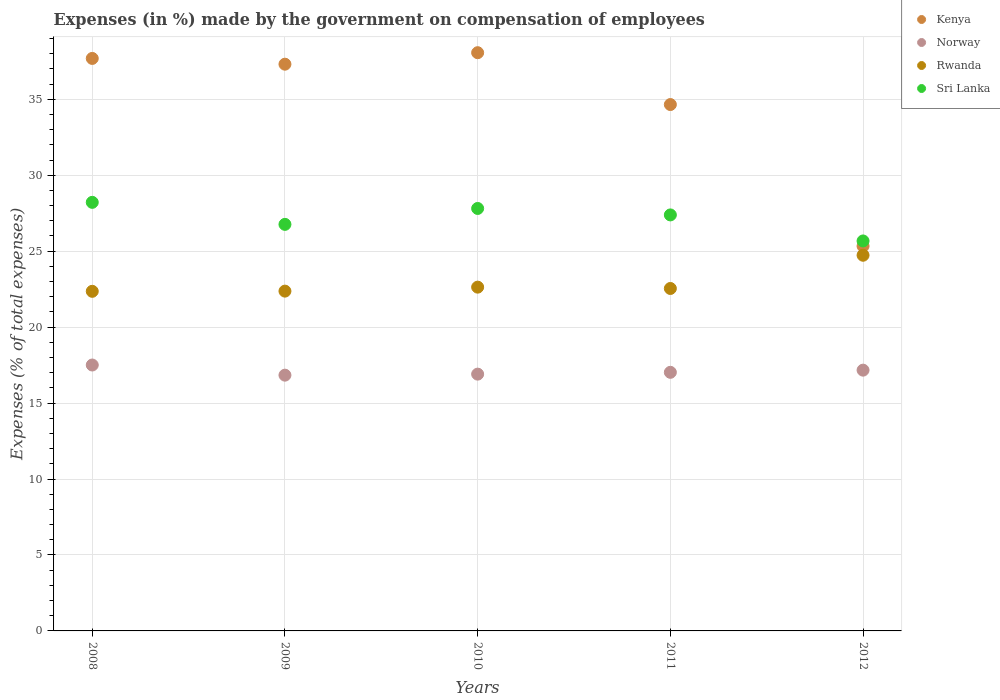Is the number of dotlines equal to the number of legend labels?
Keep it short and to the point. Yes. What is the percentage of expenses made by the government on compensation of employees in Rwanda in 2008?
Keep it short and to the point. 22.36. Across all years, what is the maximum percentage of expenses made by the government on compensation of employees in Norway?
Provide a short and direct response. 17.51. Across all years, what is the minimum percentage of expenses made by the government on compensation of employees in Rwanda?
Offer a terse response. 22.36. In which year was the percentage of expenses made by the government on compensation of employees in Norway maximum?
Offer a terse response. 2008. What is the total percentage of expenses made by the government on compensation of employees in Rwanda in the graph?
Provide a short and direct response. 114.63. What is the difference between the percentage of expenses made by the government on compensation of employees in Kenya in 2008 and that in 2012?
Your answer should be very brief. 12.36. What is the difference between the percentage of expenses made by the government on compensation of employees in Kenya in 2008 and the percentage of expenses made by the government on compensation of employees in Sri Lanka in 2010?
Give a very brief answer. 9.88. What is the average percentage of expenses made by the government on compensation of employees in Rwanda per year?
Your answer should be compact. 22.93. In the year 2008, what is the difference between the percentage of expenses made by the government on compensation of employees in Kenya and percentage of expenses made by the government on compensation of employees in Sri Lanka?
Make the answer very short. 9.47. What is the ratio of the percentage of expenses made by the government on compensation of employees in Sri Lanka in 2010 to that in 2012?
Give a very brief answer. 1.08. Is the percentage of expenses made by the government on compensation of employees in Rwanda in 2008 less than that in 2011?
Offer a very short reply. Yes. Is the difference between the percentage of expenses made by the government on compensation of employees in Kenya in 2010 and 2011 greater than the difference between the percentage of expenses made by the government on compensation of employees in Sri Lanka in 2010 and 2011?
Keep it short and to the point. Yes. What is the difference between the highest and the second highest percentage of expenses made by the government on compensation of employees in Rwanda?
Keep it short and to the point. 2.1. What is the difference between the highest and the lowest percentage of expenses made by the government on compensation of employees in Norway?
Your response must be concise. 0.67. In how many years, is the percentage of expenses made by the government on compensation of employees in Rwanda greater than the average percentage of expenses made by the government on compensation of employees in Rwanda taken over all years?
Make the answer very short. 1. Does the percentage of expenses made by the government on compensation of employees in Norway monotonically increase over the years?
Keep it short and to the point. No. How many years are there in the graph?
Your answer should be compact. 5. Does the graph contain any zero values?
Your answer should be compact. No. Does the graph contain grids?
Provide a short and direct response. Yes. How many legend labels are there?
Your answer should be compact. 4. How are the legend labels stacked?
Offer a terse response. Vertical. What is the title of the graph?
Make the answer very short. Expenses (in %) made by the government on compensation of employees. What is the label or title of the Y-axis?
Your answer should be compact. Expenses (% of total expenses). What is the Expenses (% of total expenses) of Kenya in 2008?
Provide a succinct answer. 37.69. What is the Expenses (% of total expenses) of Norway in 2008?
Ensure brevity in your answer.  17.51. What is the Expenses (% of total expenses) in Rwanda in 2008?
Your response must be concise. 22.36. What is the Expenses (% of total expenses) of Sri Lanka in 2008?
Offer a terse response. 28.21. What is the Expenses (% of total expenses) in Kenya in 2009?
Give a very brief answer. 37.31. What is the Expenses (% of total expenses) of Norway in 2009?
Make the answer very short. 16.84. What is the Expenses (% of total expenses) in Rwanda in 2009?
Offer a very short reply. 22.37. What is the Expenses (% of total expenses) in Sri Lanka in 2009?
Your answer should be compact. 26.76. What is the Expenses (% of total expenses) in Kenya in 2010?
Make the answer very short. 38.07. What is the Expenses (% of total expenses) of Norway in 2010?
Offer a terse response. 16.91. What is the Expenses (% of total expenses) in Rwanda in 2010?
Give a very brief answer. 22.63. What is the Expenses (% of total expenses) in Sri Lanka in 2010?
Give a very brief answer. 27.81. What is the Expenses (% of total expenses) of Kenya in 2011?
Offer a very short reply. 34.65. What is the Expenses (% of total expenses) in Norway in 2011?
Ensure brevity in your answer.  17.02. What is the Expenses (% of total expenses) in Rwanda in 2011?
Make the answer very short. 22.54. What is the Expenses (% of total expenses) in Sri Lanka in 2011?
Offer a terse response. 27.39. What is the Expenses (% of total expenses) in Kenya in 2012?
Keep it short and to the point. 25.33. What is the Expenses (% of total expenses) of Norway in 2012?
Your answer should be very brief. 17.17. What is the Expenses (% of total expenses) of Rwanda in 2012?
Provide a short and direct response. 24.73. What is the Expenses (% of total expenses) of Sri Lanka in 2012?
Make the answer very short. 25.67. Across all years, what is the maximum Expenses (% of total expenses) in Kenya?
Ensure brevity in your answer.  38.07. Across all years, what is the maximum Expenses (% of total expenses) of Norway?
Make the answer very short. 17.51. Across all years, what is the maximum Expenses (% of total expenses) of Rwanda?
Your response must be concise. 24.73. Across all years, what is the maximum Expenses (% of total expenses) in Sri Lanka?
Make the answer very short. 28.21. Across all years, what is the minimum Expenses (% of total expenses) in Kenya?
Your answer should be compact. 25.33. Across all years, what is the minimum Expenses (% of total expenses) of Norway?
Your answer should be very brief. 16.84. Across all years, what is the minimum Expenses (% of total expenses) of Rwanda?
Offer a very short reply. 22.36. Across all years, what is the minimum Expenses (% of total expenses) of Sri Lanka?
Provide a short and direct response. 25.67. What is the total Expenses (% of total expenses) in Kenya in the graph?
Your answer should be compact. 173.05. What is the total Expenses (% of total expenses) in Norway in the graph?
Keep it short and to the point. 85.44. What is the total Expenses (% of total expenses) in Rwanda in the graph?
Your answer should be compact. 114.63. What is the total Expenses (% of total expenses) in Sri Lanka in the graph?
Keep it short and to the point. 135.85. What is the difference between the Expenses (% of total expenses) in Kenya in 2008 and that in 2009?
Ensure brevity in your answer.  0.38. What is the difference between the Expenses (% of total expenses) of Norway in 2008 and that in 2009?
Provide a succinct answer. 0.67. What is the difference between the Expenses (% of total expenses) of Rwanda in 2008 and that in 2009?
Make the answer very short. -0.01. What is the difference between the Expenses (% of total expenses) of Sri Lanka in 2008 and that in 2009?
Your answer should be compact. 1.45. What is the difference between the Expenses (% of total expenses) of Kenya in 2008 and that in 2010?
Keep it short and to the point. -0.38. What is the difference between the Expenses (% of total expenses) of Norway in 2008 and that in 2010?
Ensure brevity in your answer.  0.6. What is the difference between the Expenses (% of total expenses) of Rwanda in 2008 and that in 2010?
Your answer should be compact. -0.27. What is the difference between the Expenses (% of total expenses) of Sri Lanka in 2008 and that in 2010?
Provide a short and direct response. 0.4. What is the difference between the Expenses (% of total expenses) in Kenya in 2008 and that in 2011?
Your answer should be compact. 3.04. What is the difference between the Expenses (% of total expenses) in Norway in 2008 and that in 2011?
Keep it short and to the point. 0.48. What is the difference between the Expenses (% of total expenses) in Rwanda in 2008 and that in 2011?
Your answer should be very brief. -0.19. What is the difference between the Expenses (% of total expenses) in Sri Lanka in 2008 and that in 2011?
Your response must be concise. 0.83. What is the difference between the Expenses (% of total expenses) of Kenya in 2008 and that in 2012?
Offer a very short reply. 12.36. What is the difference between the Expenses (% of total expenses) in Norway in 2008 and that in 2012?
Offer a terse response. 0.34. What is the difference between the Expenses (% of total expenses) of Rwanda in 2008 and that in 2012?
Offer a terse response. -2.37. What is the difference between the Expenses (% of total expenses) of Sri Lanka in 2008 and that in 2012?
Keep it short and to the point. 2.54. What is the difference between the Expenses (% of total expenses) of Kenya in 2009 and that in 2010?
Offer a terse response. -0.76. What is the difference between the Expenses (% of total expenses) in Norway in 2009 and that in 2010?
Your answer should be very brief. -0.07. What is the difference between the Expenses (% of total expenses) in Rwanda in 2009 and that in 2010?
Keep it short and to the point. -0.26. What is the difference between the Expenses (% of total expenses) in Sri Lanka in 2009 and that in 2010?
Give a very brief answer. -1.05. What is the difference between the Expenses (% of total expenses) in Kenya in 2009 and that in 2011?
Offer a very short reply. 2.66. What is the difference between the Expenses (% of total expenses) in Norway in 2009 and that in 2011?
Make the answer very short. -0.19. What is the difference between the Expenses (% of total expenses) in Rwanda in 2009 and that in 2011?
Your answer should be compact. -0.17. What is the difference between the Expenses (% of total expenses) of Sri Lanka in 2009 and that in 2011?
Offer a terse response. -0.62. What is the difference between the Expenses (% of total expenses) in Kenya in 2009 and that in 2012?
Your answer should be very brief. 11.98. What is the difference between the Expenses (% of total expenses) in Norway in 2009 and that in 2012?
Your answer should be very brief. -0.33. What is the difference between the Expenses (% of total expenses) of Rwanda in 2009 and that in 2012?
Offer a very short reply. -2.36. What is the difference between the Expenses (% of total expenses) of Sri Lanka in 2009 and that in 2012?
Your answer should be very brief. 1.09. What is the difference between the Expenses (% of total expenses) in Kenya in 2010 and that in 2011?
Provide a short and direct response. 3.41. What is the difference between the Expenses (% of total expenses) in Norway in 2010 and that in 2011?
Give a very brief answer. -0.12. What is the difference between the Expenses (% of total expenses) of Rwanda in 2010 and that in 2011?
Keep it short and to the point. 0.09. What is the difference between the Expenses (% of total expenses) in Sri Lanka in 2010 and that in 2011?
Ensure brevity in your answer.  0.43. What is the difference between the Expenses (% of total expenses) of Kenya in 2010 and that in 2012?
Provide a succinct answer. 12.73. What is the difference between the Expenses (% of total expenses) in Norway in 2010 and that in 2012?
Your response must be concise. -0.26. What is the difference between the Expenses (% of total expenses) in Rwanda in 2010 and that in 2012?
Ensure brevity in your answer.  -2.1. What is the difference between the Expenses (% of total expenses) in Sri Lanka in 2010 and that in 2012?
Make the answer very short. 2.14. What is the difference between the Expenses (% of total expenses) of Kenya in 2011 and that in 2012?
Your answer should be compact. 9.32. What is the difference between the Expenses (% of total expenses) in Norway in 2011 and that in 2012?
Your answer should be very brief. -0.14. What is the difference between the Expenses (% of total expenses) in Rwanda in 2011 and that in 2012?
Give a very brief answer. -2.19. What is the difference between the Expenses (% of total expenses) in Sri Lanka in 2011 and that in 2012?
Your answer should be compact. 1.71. What is the difference between the Expenses (% of total expenses) of Kenya in 2008 and the Expenses (% of total expenses) of Norway in 2009?
Your response must be concise. 20.85. What is the difference between the Expenses (% of total expenses) in Kenya in 2008 and the Expenses (% of total expenses) in Rwanda in 2009?
Keep it short and to the point. 15.32. What is the difference between the Expenses (% of total expenses) of Kenya in 2008 and the Expenses (% of total expenses) of Sri Lanka in 2009?
Ensure brevity in your answer.  10.92. What is the difference between the Expenses (% of total expenses) in Norway in 2008 and the Expenses (% of total expenses) in Rwanda in 2009?
Make the answer very short. -4.86. What is the difference between the Expenses (% of total expenses) of Norway in 2008 and the Expenses (% of total expenses) of Sri Lanka in 2009?
Keep it short and to the point. -9.26. What is the difference between the Expenses (% of total expenses) of Rwanda in 2008 and the Expenses (% of total expenses) of Sri Lanka in 2009?
Offer a terse response. -4.41. What is the difference between the Expenses (% of total expenses) in Kenya in 2008 and the Expenses (% of total expenses) in Norway in 2010?
Your answer should be very brief. 20.78. What is the difference between the Expenses (% of total expenses) in Kenya in 2008 and the Expenses (% of total expenses) in Rwanda in 2010?
Offer a very short reply. 15.06. What is the difference between the Expenses (% of total expenses) in Kenya in 2008 and the Expenses (% of total expenses) in Sri Lanka in 2010?
Give a very brief answer. 9.88. What is the difference between the Expenses (% of total expenses) of Norway in 2008 and the Expenses (% of total expenses) of Rwanda in 2010?
Keep it short and to the point. -5.13. What is the difference between the Expenses (% of total expenses) in Norway in 2008 and the Expenses (% of total expenses) in Sri Lanka in 2010?
Offer a very short reply. -10.31. What is the difference between the Expenses (% of total expenses) of Rwanda in 2008 and the Expenses (% of total expenses) of Sri Lanka in 2010?
Provide a short and direct response. -5.45. What is the difference between the Expenses (% of total expenses) of Kenya in 2008 and the Expenses (% of total expenses) of Norway in 2011?
Ensure brevity in your answer.  20.66. What is the difference between the Expenses (% of total expenses) of Kenya in 2008 and the Expenses (% of total expenses) of Rwanda in 2011?
Make the answer very short. 15.15. What is the difference between the Expenses (% of total expenses) of Kenya in 2008 and the Expenses (% of total expenses) of Sri Lanka in 2011?
Your answer should be compact. 10.3. What is the difference between the Expenses (% of total expenses) of Norway in 2008 and the Expenses (% of total expenses) of Rwanda in 2011?
Make the answer very short. -5.04. What is the difference between the Expenses (% of total expenses) of Norway in 2008 and the Expenses (% of total expenses) of Sri Lanka in 2011?
Your answer should be compact. -9.88. What is the difference between the Expenses (% of total expenses) in Rwanda in 2008 and the Expenses (% of total expenses) in Sri Lanka in 2011?
Ensure brevity in your answer.  -5.03. What is the difference between the Expenses (% of total expenses) in Kenya in 2008 and the Expenses (% of total expenses) in Norway in 2012?
Your answer should be very brief. 20.52. What is the difference between the Expenses (% of total expenses) in Kenya in 2008 and the Expenses (% of total expenses) in Rwanda in 2012?
Your answer should be very brief. 12.96. What is the difference between the Expenses (% of total expenses) of Kenya in 2008 and the Expenses (% of total expenses) of Sri Lanka in 2012?
Your response must be concise. 12.02. What is the difference between the Expenses (% of total expenses) of Norway in 2008 and the Expenses (% of total expenses) of Rwanda in 2012?
Provide a succinct answer. -7.23. What is the difference between the Expenses (% of total expenses) in Norway in 2008 and the Expenses (% of total expenses) in Sri Lanka in 2012?
Provide a short and direct response. -8.17. What is the difference between the Expenses (% of total expenses) in Rwanda in 2008 and the Expenses (% of total expenses) in Sri Lanka in 2012?
Make the answer very short. -3.32. What is the difference between the Expenses (% of total expenses) of Kenya in 2009 and the Expenses (% of total expenses) of Norway in 2010?
Make the answer very short. 20.4. What is the difference between the Expenses (% of total expenses) of Kenya in 2009 and the Expenses (% of total expenses) of Rwanda in 2010?
Give a very brief answer. 14.68. What is the difference between the Expenses (% of total expenses) in Kenya in 2009 and the Expenses (% of total expenses) in Sri Lanka in 2010?
Your answer should be compact. 9.5. What is the difference between the Expenses (% of total expenses) of Norway in 2009 and the Expenses (% of total expenses) of Rwanda in 2010?
Offer a very short reply. -5.79. What is the difference between the Expenses (% of total expenses) in Norway in 2009 and the Expenses (% of total expenses) in Sri Lanka in 2010?
Your answer should be very brief. -10.97. What is the difference between the Expenses (% of total expenses) of Rwanda in 2009 and the Expenses (% of total expenses) of Sri Lanka in 2010?
Your response must be concise. -5.44. What is the difference between the Expenses (% of total expenses) of Kenya in 2009 and the Expenses (% of total expenses) of Norway in 2011?
Offer a terse response. 20.29. What is the difference between the Expenses (% of total expenses) of Kenya in 2009 and the Expenses (% of total expenses) of Rwanda in 2011?
Your response must be concise. 14.77. What is the difference between the Expenses (% of total expenses) of Kenya in 2009 and the Expenses (% of total expenses) of Sri Lanka in 2011?
Keep it short and to the point. 9.92. What is the difference between the Expenses (% of total expenses) of Norway in 2009 and the Expenses (% of total expenses) of Rwanda in 2011?
Make the answer very short. -5.71. What is the difference between the Expenses (% of total expenses) of Norway in 2009 and the Expenses (% of total expenses) of Sri Lanka in 2011?
Ensure brevity in your answer.  -10.55. What is the difference between the Expenses (% of total expenses) in Rwanda in 2009 and the Expenses (% of total expenses) in Sri Lanka in 2011?
Your response must be concise. -5.02. What is the difference between the Expenses (% of total expenses) of Kenya in 2009 and the Expenses (% of total expenses) of Norway in 2012?
Provide a short and direct response. 20.14. What is the difference between the Expenses (% of total expenses) of Kenya in 2009 and the Expenses (% of total expenses) of Rwanda in 2012?
Your answer should be very brief. 12.58. What is the difference between the Expenses (% of total expenses) of Kenya in 2009 and the Expenses (% of total expenses) of Sri Lanka in 2012?
Keep it short and to the point. 11.64. What is the difference between the Expenses (% of total expenses) in Norway in 2009 and the Expenses (% of total expenses) in Rwanda in 2012?
Your answer should be very brief. -7.89. What is the difference between the Expenses (% of total expenses) of Norway in 2009 and the Expenses (% of total expenses) of Sri Lanka in 2012?
Your answer should be compact. -8.84. What is the difference between the Expenses (% of total expenses) of Rwanda in 2009 and the Expenses (% of total expenses) of Sri Lanka in 2012?
Offer a terse response. -3.3. What is the difference between the Expenses (% of total expenses) in Kenya in 2010 and the Expenses (% of total expenses) in Norway in 2011?
Your response must be concise. 21.04. What is the difference between the Expenses (% of total expenses) in Kenya in 2010 and the Expenses (% of total expenses) in Rwanda in 2011?
Provide a succinct answer. 15.52. What is the difference between the Expenses (% of total expenses) in Kenya in 2010 and the Expenses (% of total expenses) in Sri Lanka in 2011?
Provide a short and direct response. 10.68. What is the difference between the Expenses (% of total expenses) in Norway in 2010 and the Expenses (% of total expenses) in Rwanda in 2011?
Ensure brevity in your answer.  -5.64. What is the difference between the Expenses (% of total expenses) of Norway in 2010 and the Expenses (% of total expenses) of Sri Lanka in 2011?
Offer a terse response. -10.48. What is the difference between the Expenses (% of total expenses) of Rwanda in 2010 and the Expenses (% of total expenses) of Sri Lanka in 2011?
Offer a terse response. -4.76. What is the difference between the Expenses (% of total expenses) of Kenya in 2010 and the Expenses (% of total expenses) of Norway in 2012?
Your answer should be compact. 20.9. What is the difference between the Expenses (% of total expenses) of Kenya in 2010 and the Expenses (% of total expenses) of Rwanda in 2012?
Your answer should be compact. 13.33. What is the difference between the Expenses (% of total expenses) of Kenya in 2010 and the Expenses (% of total expenses) of Sri Lanka in 2012?
Your answer should be very brief. 12.39. What is the difference between the Expenses (% of total expenses) of Norway in 2010 and the Expenses (% of total expenses) of Rwanda in 2012?
Keep it short and to the point. -7.83. What is the difference between the Expenses (% of total expenses) of Norway in 2010 and the Expenses (% of total expenses) of Sri Lanka in 2012?
Ensure brevity in your answer.  -8.77. What is the difference between the Expenses (% of total expenses) in Rwanda in 2010 and the Expenses (% of total expenses) in Sri Lanka in 2012?
Your answer should be compact. -3.04. What is the difference between the Expenses (% of total expenses) in Kenya in 2011 and the Expenses (% of total expenses) in Norway in 2012?
Your answer should be very brief. 17.49. What is the difference between the Expenses (% of total expenses) in Kenya in 2011 and the Expenses (% of total expenses) in Rwanda in 2012?
Offer a very short reply. 9.92. What is the difference between the Expenses (% of total expenses) of Kenya in 2011 and the Expenses (% of total expenses) of Sri Lanka in 2012?
Your answer should be compact. 8.98. What is the difference between the Expenses (% of total expenses) in Norway in 2011 and the Expenses (% of total expenses) in Rwanda in 2012?
Your response must be concise. -7.71. What is the difference between the Expenses (% of total expenses) in Norway in 2011 and the Expenses (% of total expenses) in Sri Lanka in 2012?
Provide a short and direct response. -8.65. What is the difference between the Expenses (% of total expenses) of Rwanda in 2011 and the Expenses (% of total expenses) of Sri Lanka in 2012?
Make the answer very short. -3.13. What is the average Expenses (% of total expenses) of Kenya per year?
Give a very brief answer. 34.61. What is the average Expenses (% of total expenses) of Norway per year?
Offer a terse response. 17.09. What is the average Expenses (% of total expenses) in Rwanda per year?
Offer a very short reply. 22.93. What is the average Expenses (% of total expenses) of Sri Lanka per year?
Your answer should be very brief. 27.17. In the year 2008, what is the difference between the Expenses (% of total expenses) in Kenya and Expenses (% of total expenses) in Norway?
Offer a terse response. 20.18. In the year 2008, what is the difference between the Expenses (% of total expenses) in Kenya and Expenses (% of total expenses) in Rwanda?
Keep it short and to the point. 15.33. In the year 2008, what is the difference between the Expenses (% of total expenses) of Kenya and Expenses (% of total expenses) of Sri Lanka?
Provide a short and direct response. 9.47. In the year 2008, what is the difference between the Expenses (% of total expenses) of Norway and Expenses (% of total expenses) of Rwanda?
Offer a very short reply. -4.85. In the year 2008, what is the difference between the Expenses (% of total expenses) in Norway and Expenses (% of total expenses) in Sri Lanka?
Provide a succinct answer. -10.71. In the year 2008, what is the difference between the Expenses (% of total expenses) in Rwanda and Expenses (% of total expenses) in Sri Lanka?
Your answer should be very brief. -5.86. In the year 2009, what is the difference between the Expenses (% of total expenses) of Kenya and Expenses (% of total expenses) of Norway?
Provide a short and direct response. 20.47. In the year 2009, what is the difference between the Expenses (% of total expenses) in Kenya and Expenses (% of total expenses) in Rwanda?
Ensure brevity in your answer.  14.94. In the year 2009, what is the difference between the Expenses (% of total expenses) of Kenya and Expenses (% of total expenses) of Sri Lanka?
Your answer should be very brief. 10.55. In the year 2009, what is the difference between the Expenses (% of total expenses) in Norway and Expenses (% of total expenses) in Rwanda?
Provide a short and direct response. -5.53. In the year 2009, what is the difference between the Expenses (% of total expenses) in Norway and Expenses (% of total expenses) in Sri Lanka?
Offer a very short reply. -9.93. In the year 2009, what is the difference between the Expenses (% of total expenses) of Rwanda and Expenses (% of total expenses) of Sri Lanka?
Your answer should be very brief. -4.39. In the year 2010, what is the difference between the Expenses (% of total expenses) of Kenya and Expenses (% of total expenses) of Norway?
Ensure brevity in your answer.  21.16. In the year 2010, what is the difference between the Expenses (% of total expenses) in Kenya and Expenses (% of total expenses) in Rwanda?
Keep it short and to the point. 15.43. In the year 2010, what is the difference between the Expenses (% of total expenses) in Kenya and Expenses (% of total expenses) in Sri Lanka?
Give a very brief answer. 10.25. In the year 2010, what is the difference between the Expenses (% of total expenses) of Norway and Expenses (% of total expenses) of Rwanda?
Offer a terse response. -5.73. In the year 2010, what is the difference between the Expenses (% of total expenses) of Norway and Expenses (% of total expenses) of Sri Lanka?
Offer a very short reply. -10.91. In the year 2010, what is the difference between the Expenses (% of total expenses) of Rwanda and Expenses (% of total expenses) of Sri Lanka?
Offer a very short reply. -5.18. In the year 2011, what is the difference between the Expenses (% of total expenses) of Kenya and Expenses (% of total expenses) of Norway?
Give a very brief answer. 17.63. In the year 2011, what is the difference between the Expenses (% of total expenses) in Kenya and Expenses (% of total expenses) in Rwanda?
Your response must be concise. 12.11. In the year 2011, what is the difference between the Expenses (% of total expenses) of Kenya and Expenses (% of total expenses) of Sri Lanka?
Your response must be concise. 7.27. In the year 2011, what is the difference between the Expenses (% of total expenses) in Norway and Expenses (% of total expenses) in Rwanda?
Make the answer very short. -5.52. In the year 2011, what is the difference between the Expenses (% of total expenses) in Norway and Expenses (% of total expenses) in Sri Lanka?
Provide a short and direct response. -10.36. In the year 2011, what is the difference between the Expenses (% of total expenses) of Rwanda and Expenses (% of total expenses) of Sri Lanka?
Your answer should be very brief. -4.84. In the year 2012, what is the difference between the Expenses (% of total expenses) of Kenya and Expenses (% of total expenses) of Norway?
Your response must be concise. 8.17. In the year 2012, what is the difference between the Expenses (% of total expenses) in Kenya and Expenses (% of total expenses) in Rwanda?
Make the answer very short. 0.6. In the year 2012, what is the difference between the Expenses (% of total expenses) in Kenya and Expenses (% of total expenses) in Sri Lanka?
Your answer should be very brief. -0.34. In the year 2012, what is the difference between the Expenses (% of total expenses) of Norway and Expenses (% of total expenses) of Rwanda?
Your response must be concise. -7.56. In the year 2012, what is the difference between the Expenses (% of total expenses) in Norway and Expenses (% of total expenses) in Sri Lanka?
Keep it short and to the point. -8.51. In the year 2012, what is the difference between the Expenses (% of total expenses) of Rwanda and Expenses (% of total expenses) of Sri Lanka?
Your answer should be compact. -0.94. What is the ratio of the Expenses (% of total expenses) in Kenya in 2008 to that in 2009?
Give a very brief answer. 1.01. What is the ratio of the Expenses (% of total expenses) in Norway in 2008 to that in 2009?
Keep it short and to the point. 1.04. What is the ratio of the Expenses (% of total expenses) of Sri Lanka in 2008 to that in 2009?
Offer a very short reply. 1.05. What is the ratio of the Expenses (% of total expenses) in Kenya in 2008 to that in 2010?
Offer a very short reply. 0.99. What is the ratio of the Expenses (% of total expenses) of Norway in 2008 to that in 2010?
Your answer should be very brief. 1.04. What is the ratio of the Expenses (% of total expenses) of Rwanda in 2008 to that in 2010?
Ensure brevity in your answer.  0.99. What is the ratio of the Expenses (% of total expenses) of Sri Lanka in 2008 to that in 2010?
Your answer should be very brief. 1.01. What is the ratio of the Expenses (% of total expenses) of Kenya in 2008 to that in 2011?
Your response must be concise. 1.09. What is the ratio of the Expenses (% of total expenses) of Norway in 2008 to that in 2011?
Provide a succinct answer. 1.03. What is the ratio of the Expenses (% of total expenses) in Rwanda in 2008 to that in 2011?
Your response must be concise. 0.99. What is the ratio of the Expenses (% of total expenses) in Sri Lanka in 2008 to that in 2011?
Your answer should be compact. 1.03. What is the ratio of the Expenses (% of total expenses) in Kenya in 2008 to that in 2012?
Ensure brevity in your answer.  1.49. What is the ratio of the Expenses (% of total expenses) of Norway in 2008 to that in 2012?
Offer a terse response. 1.02. What is the ratio of the Expenses (% of total expenses) of Rwanda in 2008 to that in 2012?
Offer a very short reply. 0.9. What is the ratio of the Expenses (% of total expenses) in Sri Lanka in 2008 to that in 2012?
Provide a short and direct response. 1.1. What is the ratio of the Expenses (% of total expenses) in Kenya in 2009 to that in 2010?
Offer a very short reply. 0.98. What is the ratio of the Expenses (% of total expenses) of Rwanda in 2009 to that in 2010?
Your answer should be very brief. 0.99. What is the ratio of the Expenses (% of total expenses) in Sri Lanka in 2009 to that in 2010?
Offer a terse response. 0.96. What is the ratio of the Expenses (% of total expenses) of Kenya in 2009 to that in 2011?
Keep it short and to the point. 1.08. What is the ratio of the Expenses (% of total expenses) in Norway in 2009 to that in 2011?
Give a very brief answer. 0.99. What is the ratio of the Expenses (% of total expenses) of Sri Lanka in 2009 to that in 2011?
Make the answer very short. 0.98. What is the ratio of the Expenses (% of total expenses) in Kenya in 2009 to that in 2012?
Make the answer very short. 1.47. What is the ratio of the Expenses (% of total expenses) in Norway in 2009 to that in 2012?
Make the answer very short. 0.98. What is the ratio of the Expenses (% of total expenses) of Rwanda in 2009 to that in 2012?
Offer a terse response. 0.9. What is the ratio of the Expenses (% of total expenses) of Sri Lanka in 2009 to that in 2012?
Make the answer very short. 1.04. What is the ratio of the Expenses (% of total expenses) in Kenya in 2010 to that in 2011?
Make the answer very short. 1.1. What is the ratio of the Expenses (% of total expenses) in Norway in 2010 to that in 2011?
Offer a terse response. 0.99. What is the ratio of the Expenses (% of total expenses) in Sri Lanka in 2010 to that in 2011?
Offer a very short reply. 1.02. What is the ratio of the Expenses (% of total expenses) of Kenya in 2010 to that in 2012?
Your answer should be very brief. 1.5. What is the ratio of the Expenses (% of total expenses) in Norway in 2010 to that in 2012?
Provide a succinct answer. 0.98. What is the ratio of the Expenses (% of total expenses) in Rwanda in 2010 to that in 2012?
Offer a very short reply. 0.92. What is the ratio of the Expenses (% of total expenses) of Kenya in 2011 to that in 2012?
Your answer should be very brief. 1.37. What is the ratio of the Expenses (% of total expenses) in Norway in 2011 to that in 2012?
Your answer should be very brief. 0.99. What is the ratio of the Expenses (% of total expenses) in Rwanda in 2011 to that in 2012?
Give a very brief answer. 0.91. What is the ratio of the Expenses (% of total expenses) of Sri Lanka in 2011 to that in 2012?
Provide a short and direct response. 1.07. What is the difference between the highest and the second highest Expenses (% of total expenses) in Kenya?
Offer a terse response. 0.38. What is the difference between the highest and the second highest Expenses (% of total expenses) of Norway?
Make the answer very short. 0.34. What is the difference between the highest and the second highest Expenses (% of total expenses) in Rwanda?
Provide a succinct answer. 2.1. What is the difference between the highest and the second highest Expenses (% of total expenses) of Sri Lanka?
Make the answer very short. 0.4. What is the difference between the highest and the lowest Expenses (% of total expenses) of Kenya?
Ensure brevity in your answer.  12.73. What is the difference between the highest and the lowest Expenses (% of total expenses) of Norway?
Your answer should be compact. 0.67. What is the difference between the highest and the lowest Expenses (% of total expenses) of Rwanda?
Your response must be concise. 2.37. What is the difference between the highest and the lowest Expenses (% of total expenses) in Sri Lanka?
Your response must be concise. 2.54. 